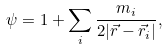<formula> <loc_0><loc_0><loc_500><loc_500>\psi = 1 + \sum _ { i } \frac { m _ { i } } { 2 | \vec { r } - \vec { r } _ { i } | } ,</formula> 